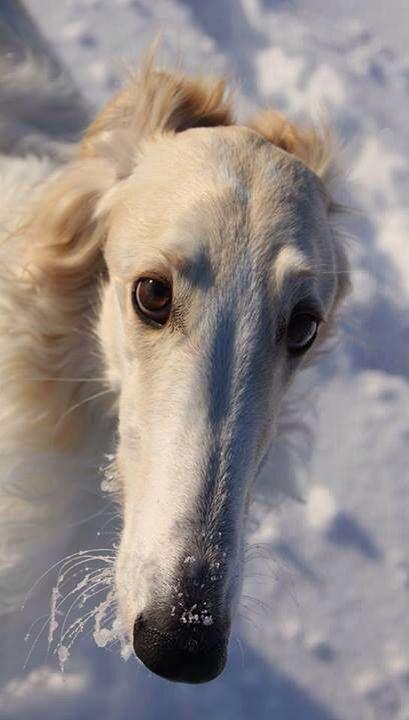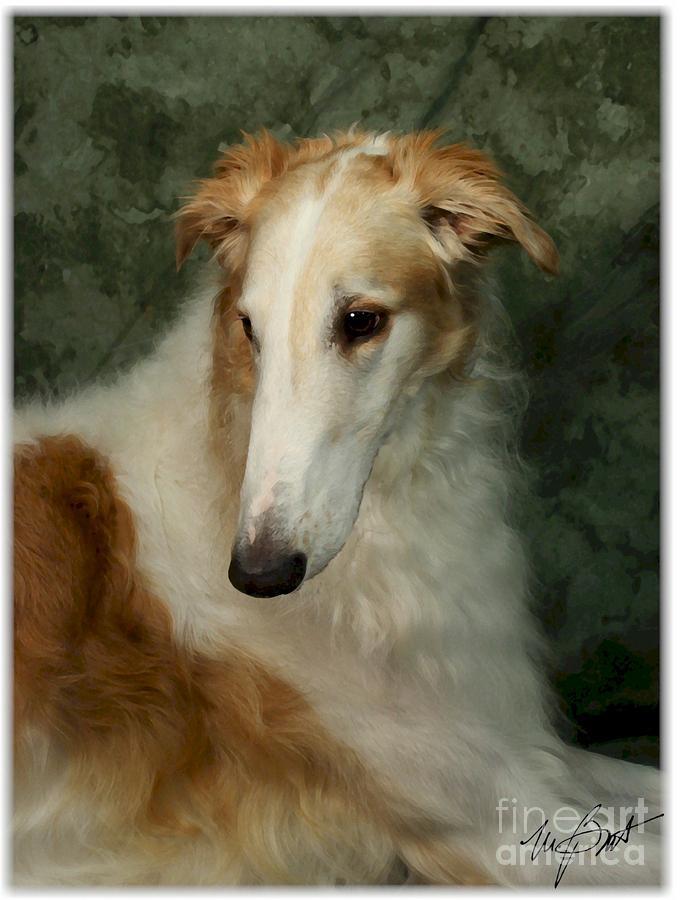The first image is the image on the left, the second image is the image on the right. Evaluate the accuracy of this statement regarding the images: "The dog in one of the images is lying down on a piece of furniture.". Is it true? Answer yes or no. No. 